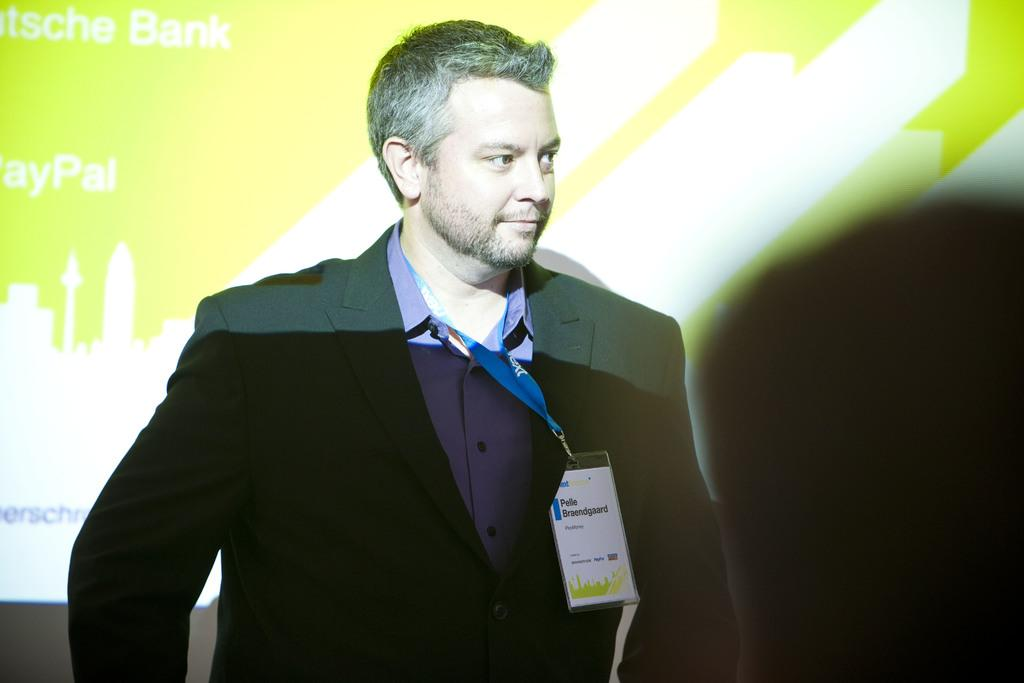Who is in the image? There is a man in the image. What is the man wearing on his upper body? The man is wearing a blue shirt and a black coat. Does the man have any identifiers in the image? Yes, the man has a tag. What can be seen on the right side of the image? There is a black background with a banner on it. What is written on the banner? There is text on the banner. Can you tell me how many times the man jumps in the image? There is no indication of the man jumping in the image. Where does the man rest in the image? The image does not show the man resting; he is standing with a tag. 